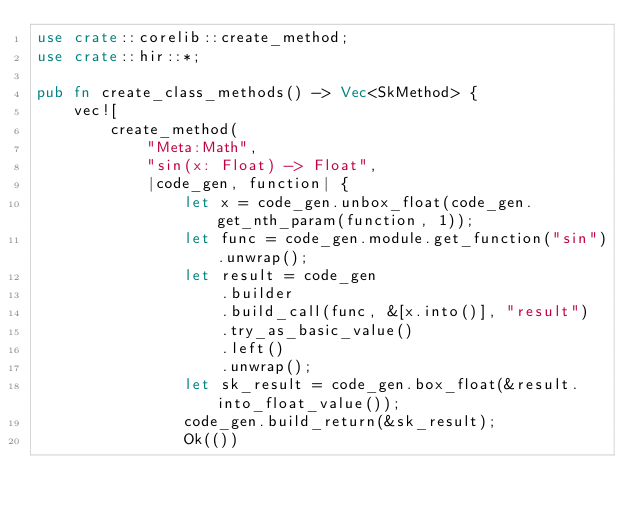Convert code to text. <code><loc_0><loc_0><loc_500><loc_500><_Rust_>use crate::corelib::create_method;
use crate::hir::*;

pub fn create_class_methods() -> Vec<SkMethod> {
    vec![
        create_method(
            "Meta:Math",
            "sin(x: Float) -> Float",
            |code_gen, function| {
                let x = code_gen.unbox_float(code_gen.get_nth_param(function, 1));
                let func = code_gen.module.get_function("sin").unwrap();
                let result = code_gen
                    .builder
                    .build_call(func, &[x.into()], "result")
                    .try_as_basic_value()
                    .left()
                    .unwrap();
                let sk_result = code_gen.box_float(&result.into_float_value());
                code_gen.build_return(&sk_result);
                Ok(())</code> 